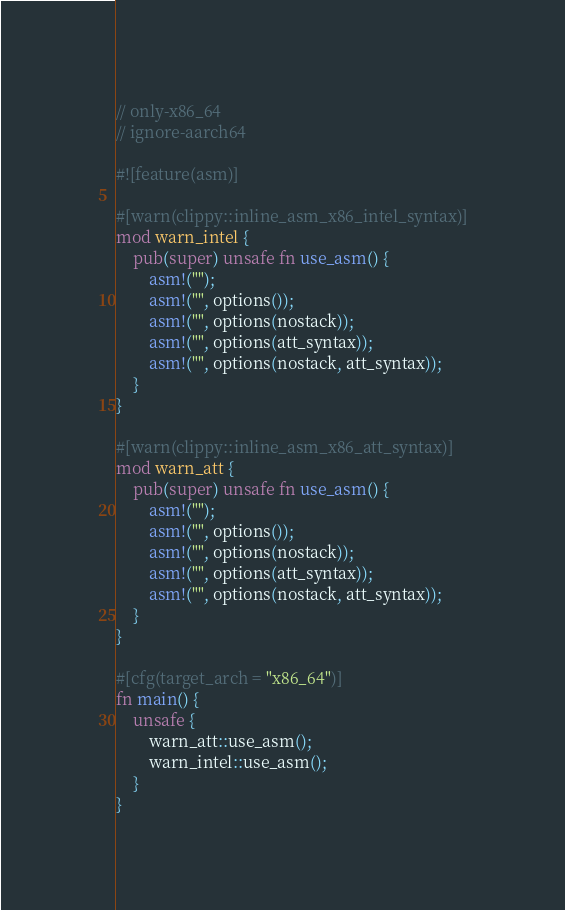Convert code to text. <code><loc_0><loc_0><loc_500><loc_500><_Rust_>// only-x86_64
// ignore-aarch64

#![feature(asm)]

#[warn(clippy::inline_asm_x86_intel_syntax)]
mod warn_intel {
    pub(super) unsafe fn use_asm() {
        asm!("");
        asm!("", options());
        asm!("", options(nostack));
        asm!("", options(att_syntax));
        asm!("", options(nostack, att_syntax));
    }
}

#[warn(clippy::inline_asm_x86_att_syntax)]
mod warn_att {
    pub(super) unsafe fn use_asm() {
        asm!("");
        asm!("", options());
        asm!("", options(nostack));
        asm!("", options(att_syntax));
        asm!("", options(nostack, att_syntax));
    }
}

#[cfg(target_arch = "x86_64")]
fn main() {
    unsafe {
        warn_att::use_asm();
        warn_intel::use_asm();
    }
}
</code> 